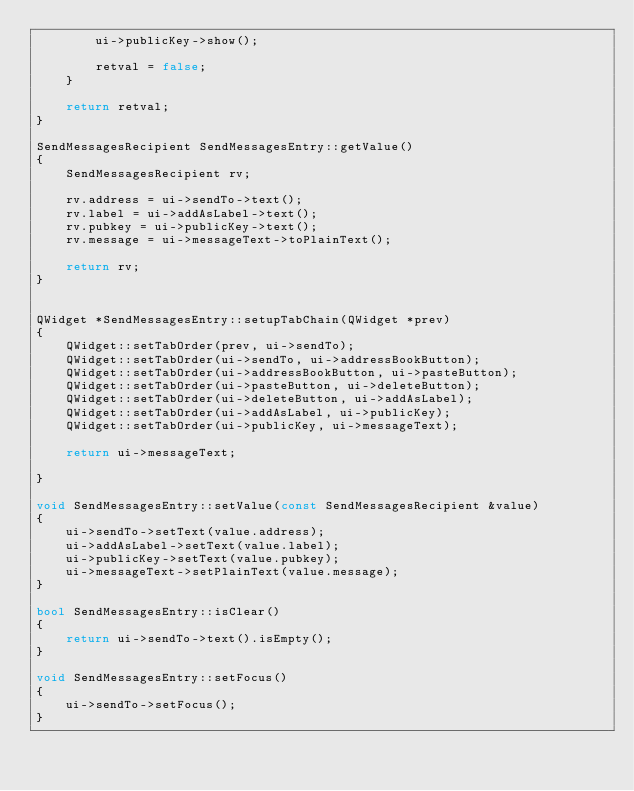Convert code to text. <code><loc_0><loc_0><loc_500><loc_500><_C++_>        ui->publicKey->show();

        retval = false;
    }

    return retval;
}

SendMessagesRecipient SendMessagesEntry::getValue()
{
    SendMessagesRecipient rv;

    rv.address = ui->sendTo->text();
    rv.label = ui->addAsLabel->text();
    rv.pubkey = ui->publicKey->text();
    rv.message = ui->messageText->toPlainText();

    return rv;
}


QWidget *SendMessagesEntry::setupTabChain(QWidget *prev)
{
    QWidget::setTabOrder(prev, ui->sendTo);
    QWidget::setTabOrder(ui->sendTo, ui->addressBookButton);
    QWidget::setTabOrder(ui->addressBookButton, ui->pasteButton);
    QWidget::setTabOrder(ui->pasteButton, ui->deleteButton);
    QWidget::setTabOrder(ui->deleteButton, ui->addAsLabel);
    QWidget::setTabOrder(ui->addAsLabel, ui->publicKey);
    QWidget::setTabOrder(ui->publicKey, ui->messageText);

    return ui->messageText;

}

void SendMessagesEntry::setValue(const SendMessagesRecipient &value)
{
    ui->sendTo->setText(value.address);
    ui->addAsLabel->setText(value.label);
    ui->publicKey->setText(value.pubkey);
    ui->messageText->setPlainText(value.message);
}

bool SendMessagesEntry::isClear()
{
    return ui->sendTo->text().isEmpty();
}

void SendMessagesEntry::setFocus()
{
    ui->sendTo->setFocus();
}
</code> 